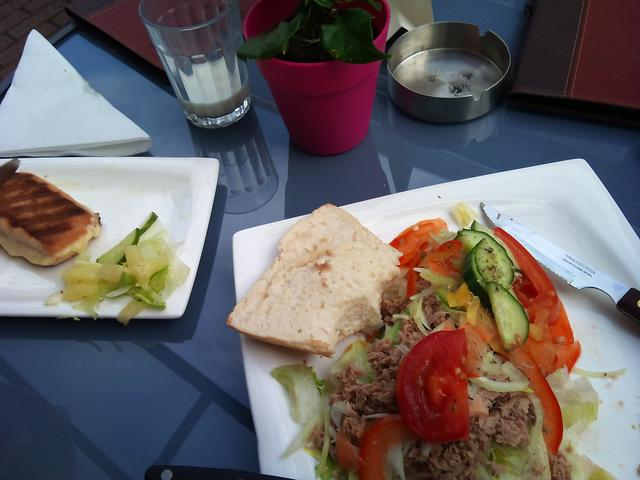What do the stains on the middle top metal thing come from? cigarettes 